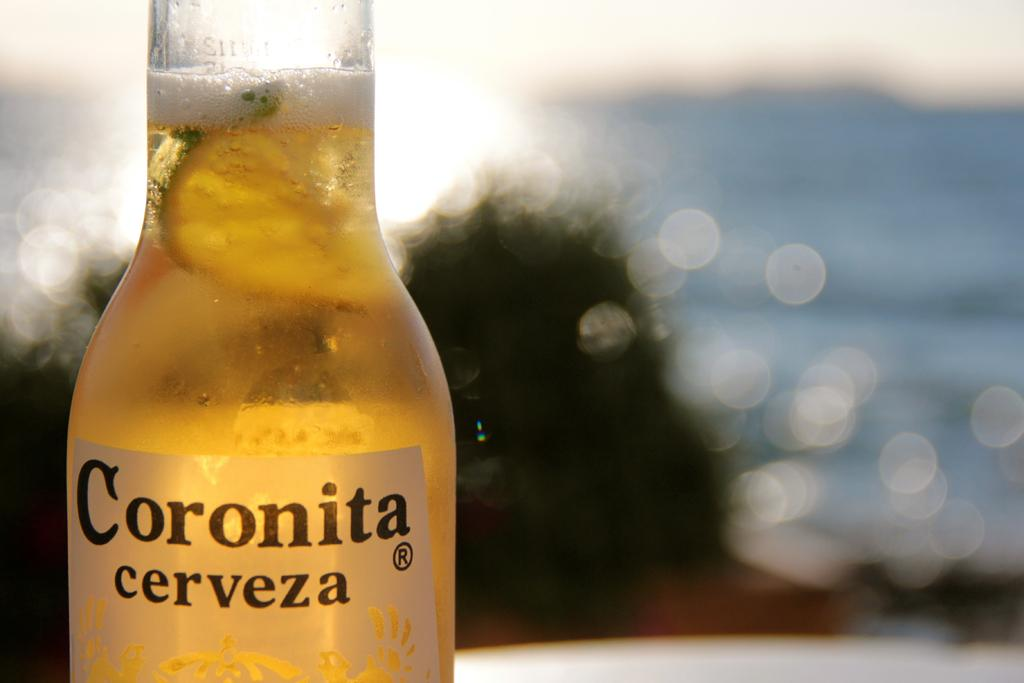<image>
Provide a brief description of the given image. A bottle of Coronita cerveza with the water in the background. 